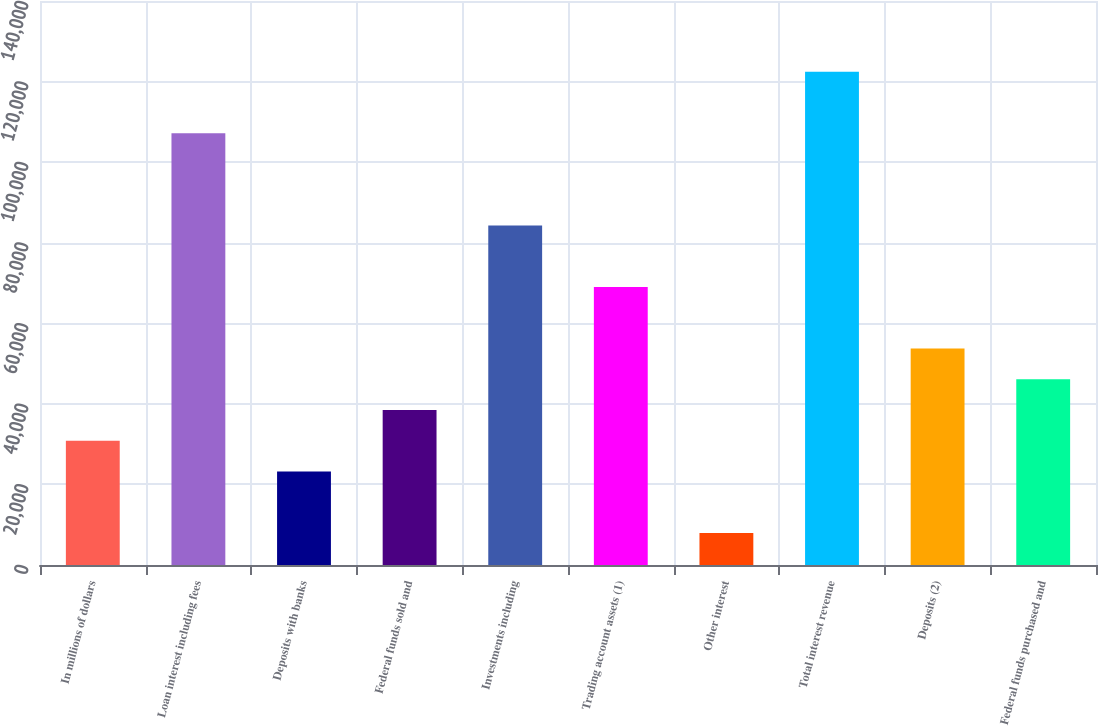Convert chart. <chart><loc_0><loc_0><loc_500><loc_500><bar_chart><fcel>In millions of dollars<fcel>Loan interest including fees<fcel>Deposits with banks<fcel>Federal funds sold and<fcel>Investments including<fcel>Trading account assets (1)<fcel>Other interest<fcel>Total interest revenue<fcel>Deposits (2)<fcel>Federal funds purchased and<nl><fcel>30827.4<fcel>107173<fcel>23192.8<fcel>38462<fcel>84269.6<fcel>69000.4<fcel>7923.6<fcel>122443<fcel>53731.2<fcel>46096.6<nl></chart> 